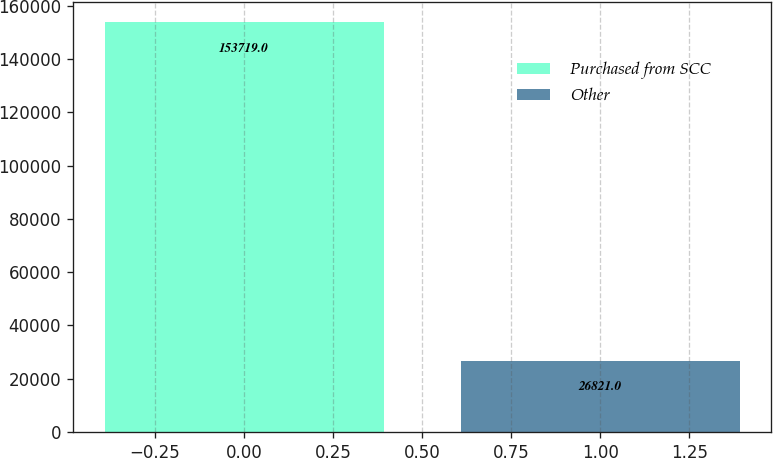<chart> <loc_0><loc_0><loc_500><loc_500><bar_chart><fcel>Purchased from SCC<fcel>Other<nl><fcel>153719<fcel>26821<nl></chart> 